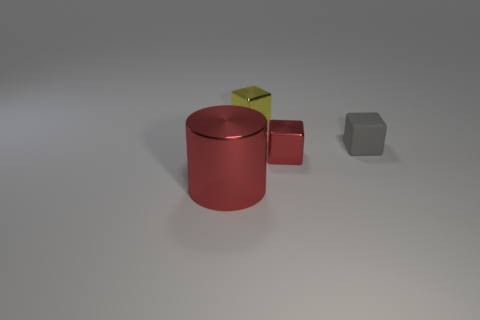Is there anything else that is the same size as the cylinder?
Your response must be concise. No. What is the shape of the small object behind the small gray rubber thing?
Your answer should be very brief. Cube. Do the red block and the yellow metal cube on the left side of the tiny gray thing have the same size?
Keep it short and to the point. Yes. Are there any small yellow blocks that have the same material as the small yellow thing?
Make the answer very short. No. What number of cubes are tiny objects or large red things?
Keep it short and to the point. 3. Is there a gray matte block that is in front of the metal object that is behind the red block?
Offer a very short reply. Yes. Is the number of yellow cylinders less than the number of big metallic objects?
Keep it short and to the point. Yes. How many other small things are the same shape as the yellow thing?
Your answer should be compact. 2. What number of blue objects are either shiny objects or small things?
Ensure brevity in your answer.  0. How big is the cube on the left side of the red metallic object that is behind the large red metallic cylinder?
Your response must be concise. Small. 